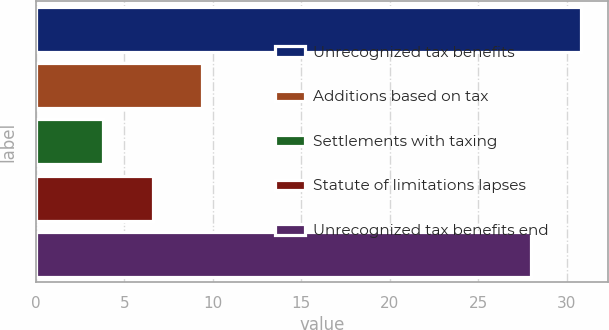Convert chart. <chart><loc_0><loc_0><loc_500><loc_500><bar_chart><fcel>Unrecognized tax benefits<fcel>Additions based on tax<fcel>Settlements with taxing<fcel>Statute of limitations lapses<fcel>Unrecognized tax benefits end<nl><fcel>30.8<fcel>9.4<fcel>3.8<fcel>6.6<fcel>28<nl></chart> 